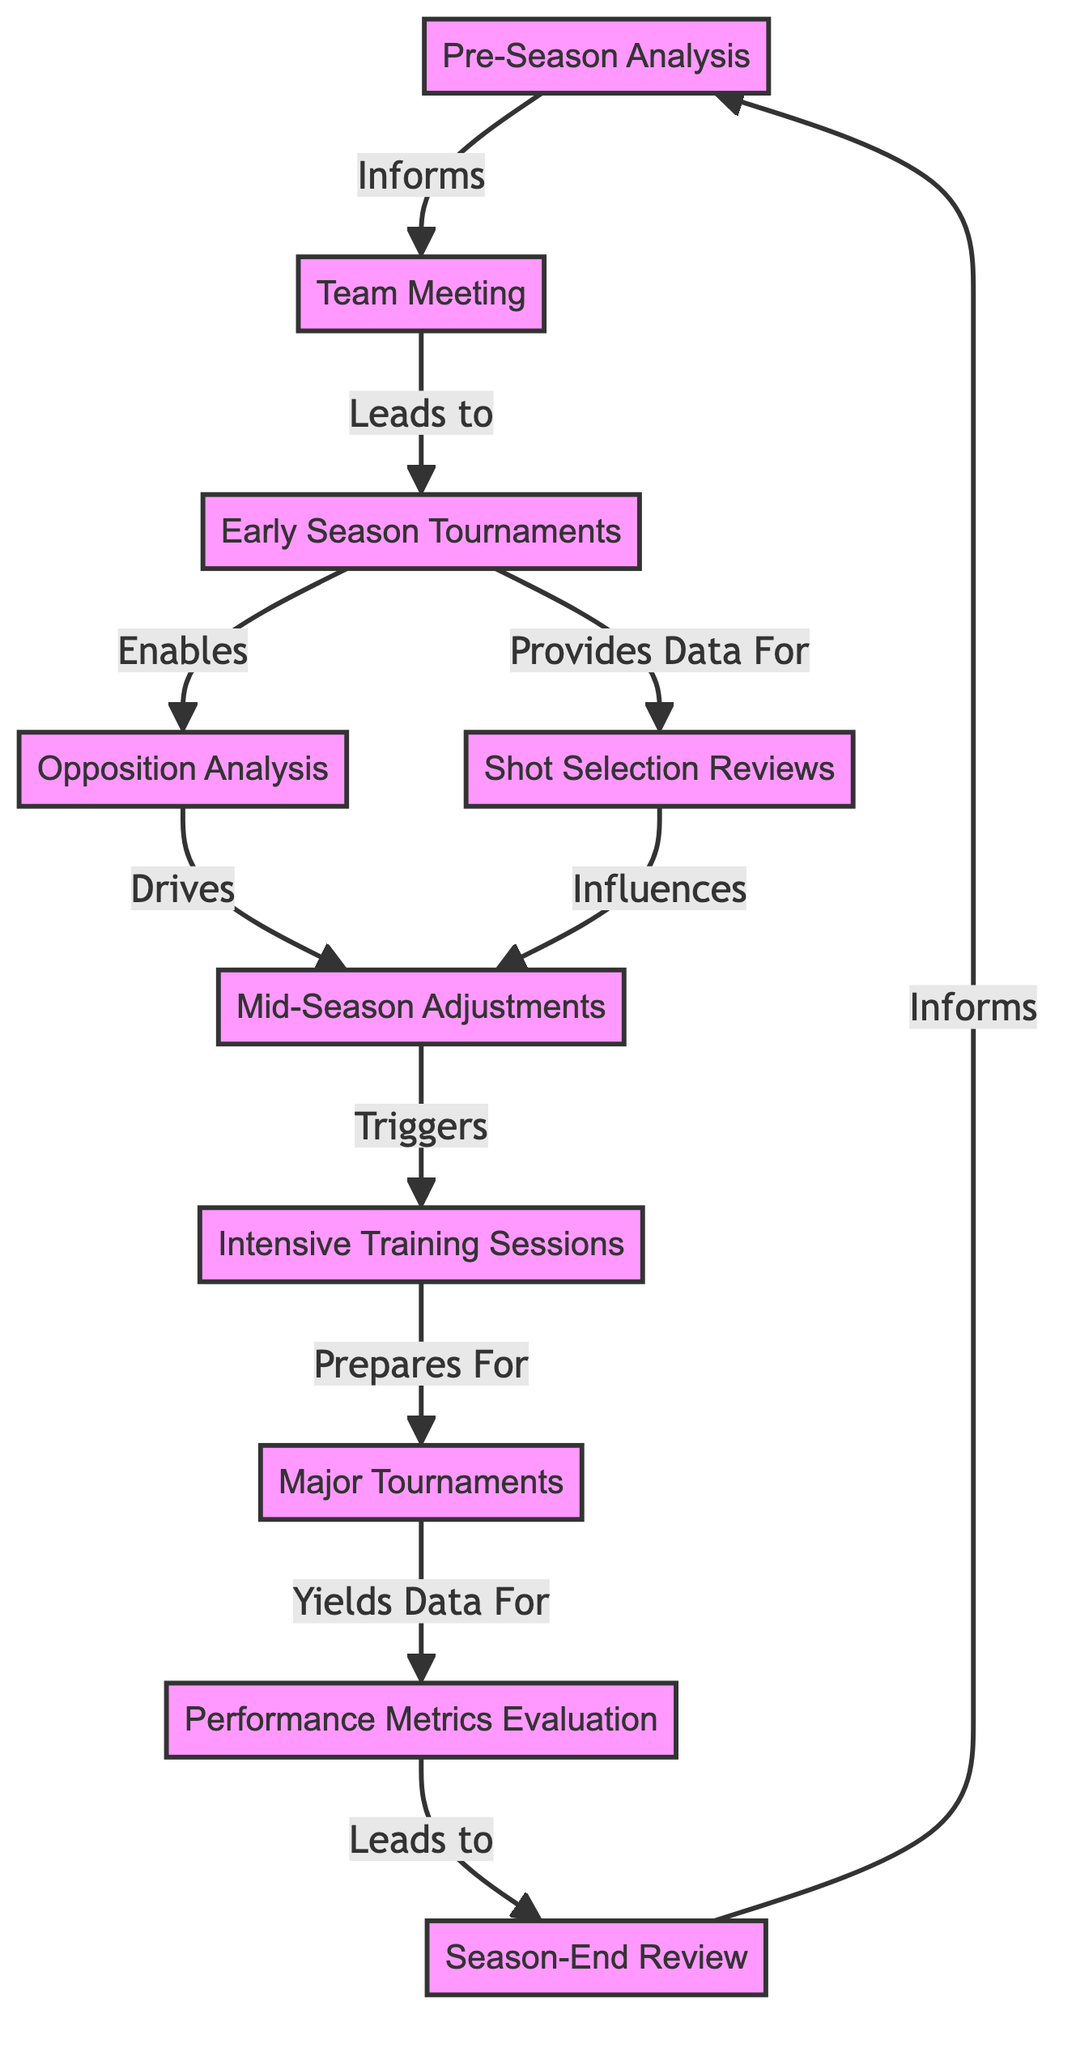What is the first step in the strategy evolution process? The first step is "Pre-Season Analysis," which suggests that the team reviews last season's performance before the new season starts.
Answer: Pre-Season Analysis How many nodes are present in this directed graph? By counting the listed nodes, we find that there are a total of ten nodes in the graph representing various stages of strategy evolution.
Answer: 10 Which node leads to "Early Season Tournaments"? The node "Team Meeting" directly leads to "Early Season Tournaments," indicating that discussions in team meetings result in early competitive actions.
Answer: Team Meeting What does "Shot Selection Reviews" influence? "Shot Selection Reviews" influences "Mid-Season Adjustments," suggesting that the evaluation of shot choices has a direct impact on mid-season strategy changes.
Answer: Mid-Season Adjustments What is the relationship between "Major Tournaments" and "Performance Metrics Evaluation"? "Major Tournaments" yields data for "Performance Metrics Evaluation," indicating that the outcomes and data from tournaments are analyzed to assess team performance.
Answer: Yields Data For Which node is analyzed in both pre-season and season-end processes? The node "Performance Metrics Evaluation" is evaluated following "Major Tournaments" and then feeds into the "Season-End Review," indicating its importance at both stages of season analysis.
Answer: Performance Metrics Evaluation How does "Mid-Season Adjustments" affect team training? "Mid-Season Adjustments" triggers "Intensive Training Sessions," meaning that after adjustments are made, the team focuses on specific areas to improve performance.
Answer: Triggers What step comes immediately after "Intensive Training Sessions"? The step that comes immediately after "Intensive Training Sessions" is "Major Tournaments," meaning intensive training directly prepares the team for key competitions.
Answer: Major Tournaments What type of analysis is performed at the start of the season? "Opposition Analysis" is performed as part of the overall strategy during early tournaments to tailor tactics against future opponents.
Answer: Opposition Analysis 